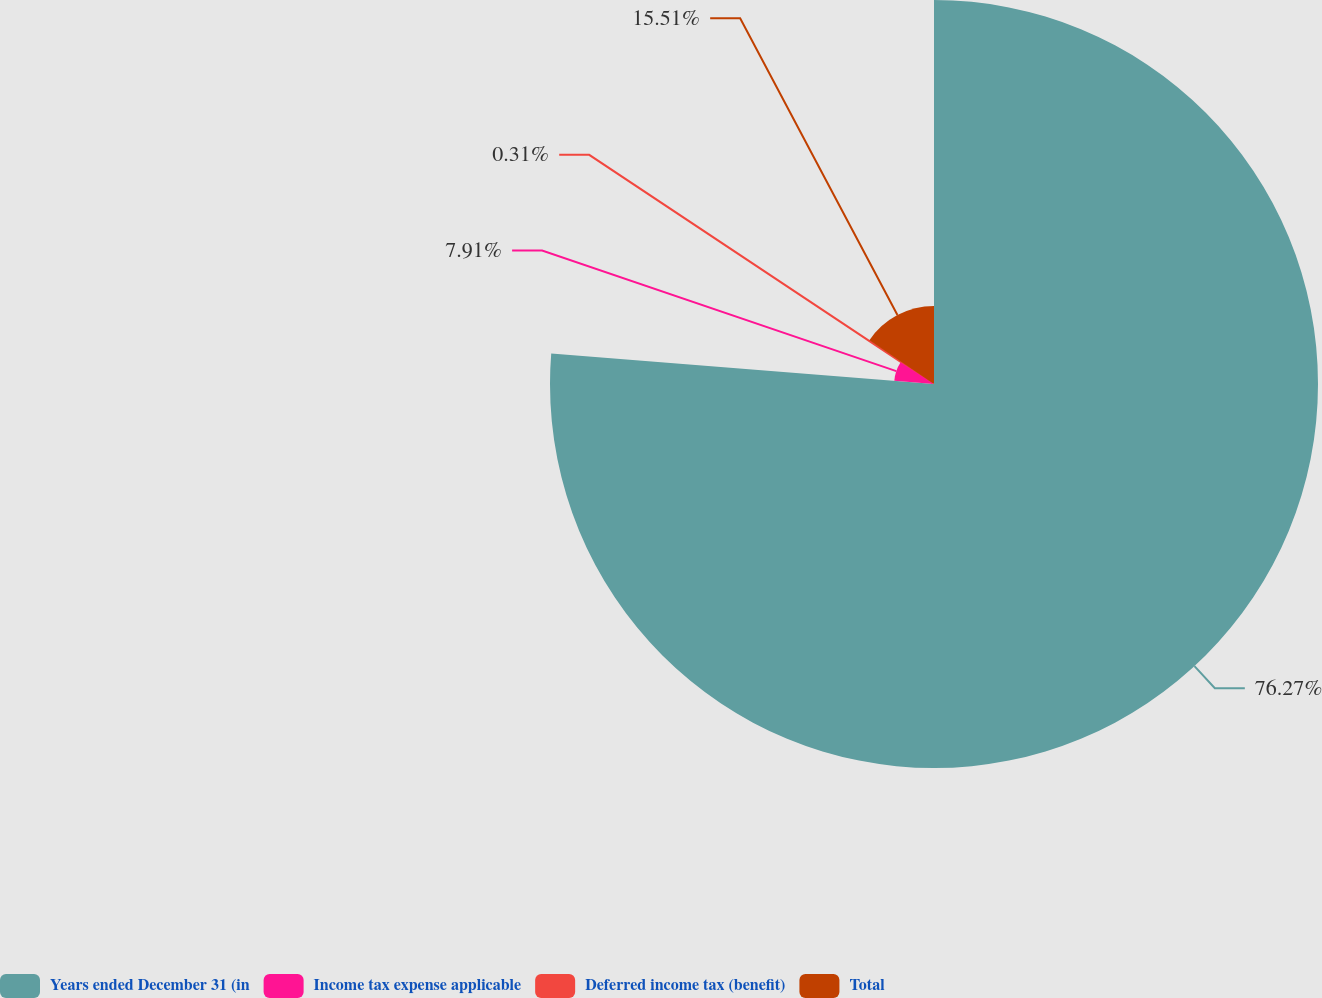Convert chart to OTSL. <chart><loc_0><loc_0><loc_500><loc_500><pie_chart><fcel>Years ended December 31 (in<fcel>Income tax expense applicable<fcel>Deferred income tax (benefit)<fcel>Total<nl><fcel>76.27%<fcel>7.91%<fcel>0.31%<fcel>15.51%<nl></chart> 